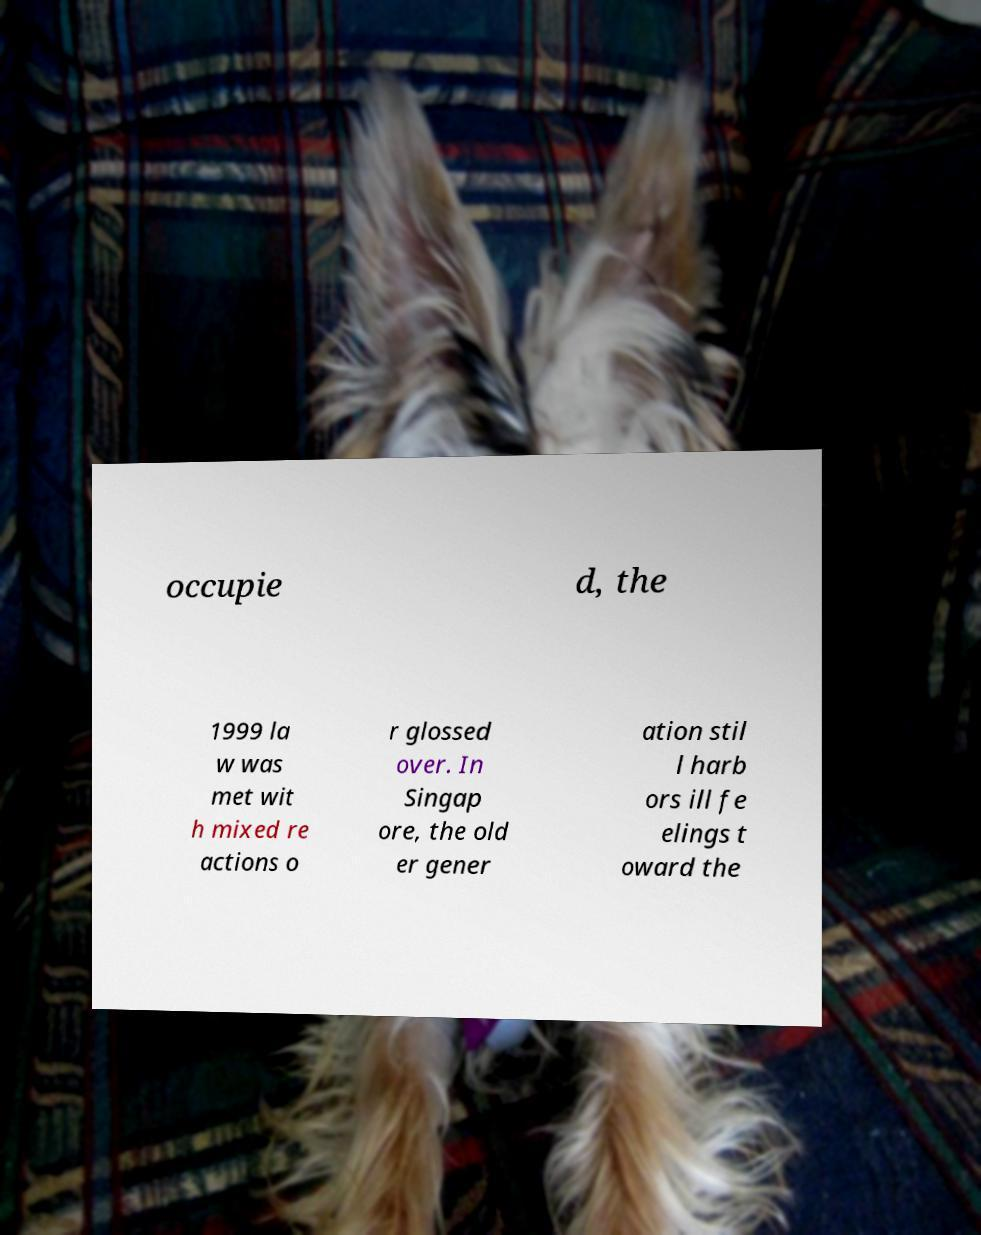Please identify and transcribe the text found in this image. occupie d, the 1999 la w was met wit h mixed re actions o r glossed over. In Singap ore, the old er gener ation stil l harb ors ill fe elings t oward the 